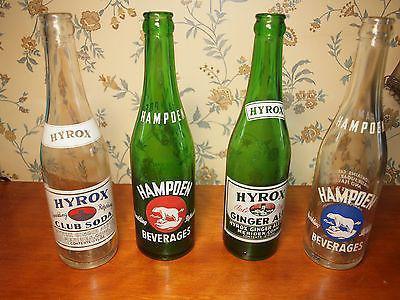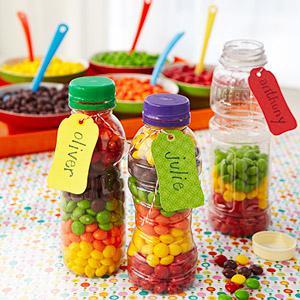The first image is the image on the left, the second image is the image on the right. Assess this claim about the two images: "In one image the bottles are made of glass and the other has plastic bottles". Correct or not? Answer yes or no. Yes. The first image is the image on the left, the second image is the image on the right. For the images displayed, is the sentence "The right image includes at least three upright bottles with multicolored candies on the surface next to them." factually correct? Answer yes or no. Yes. 